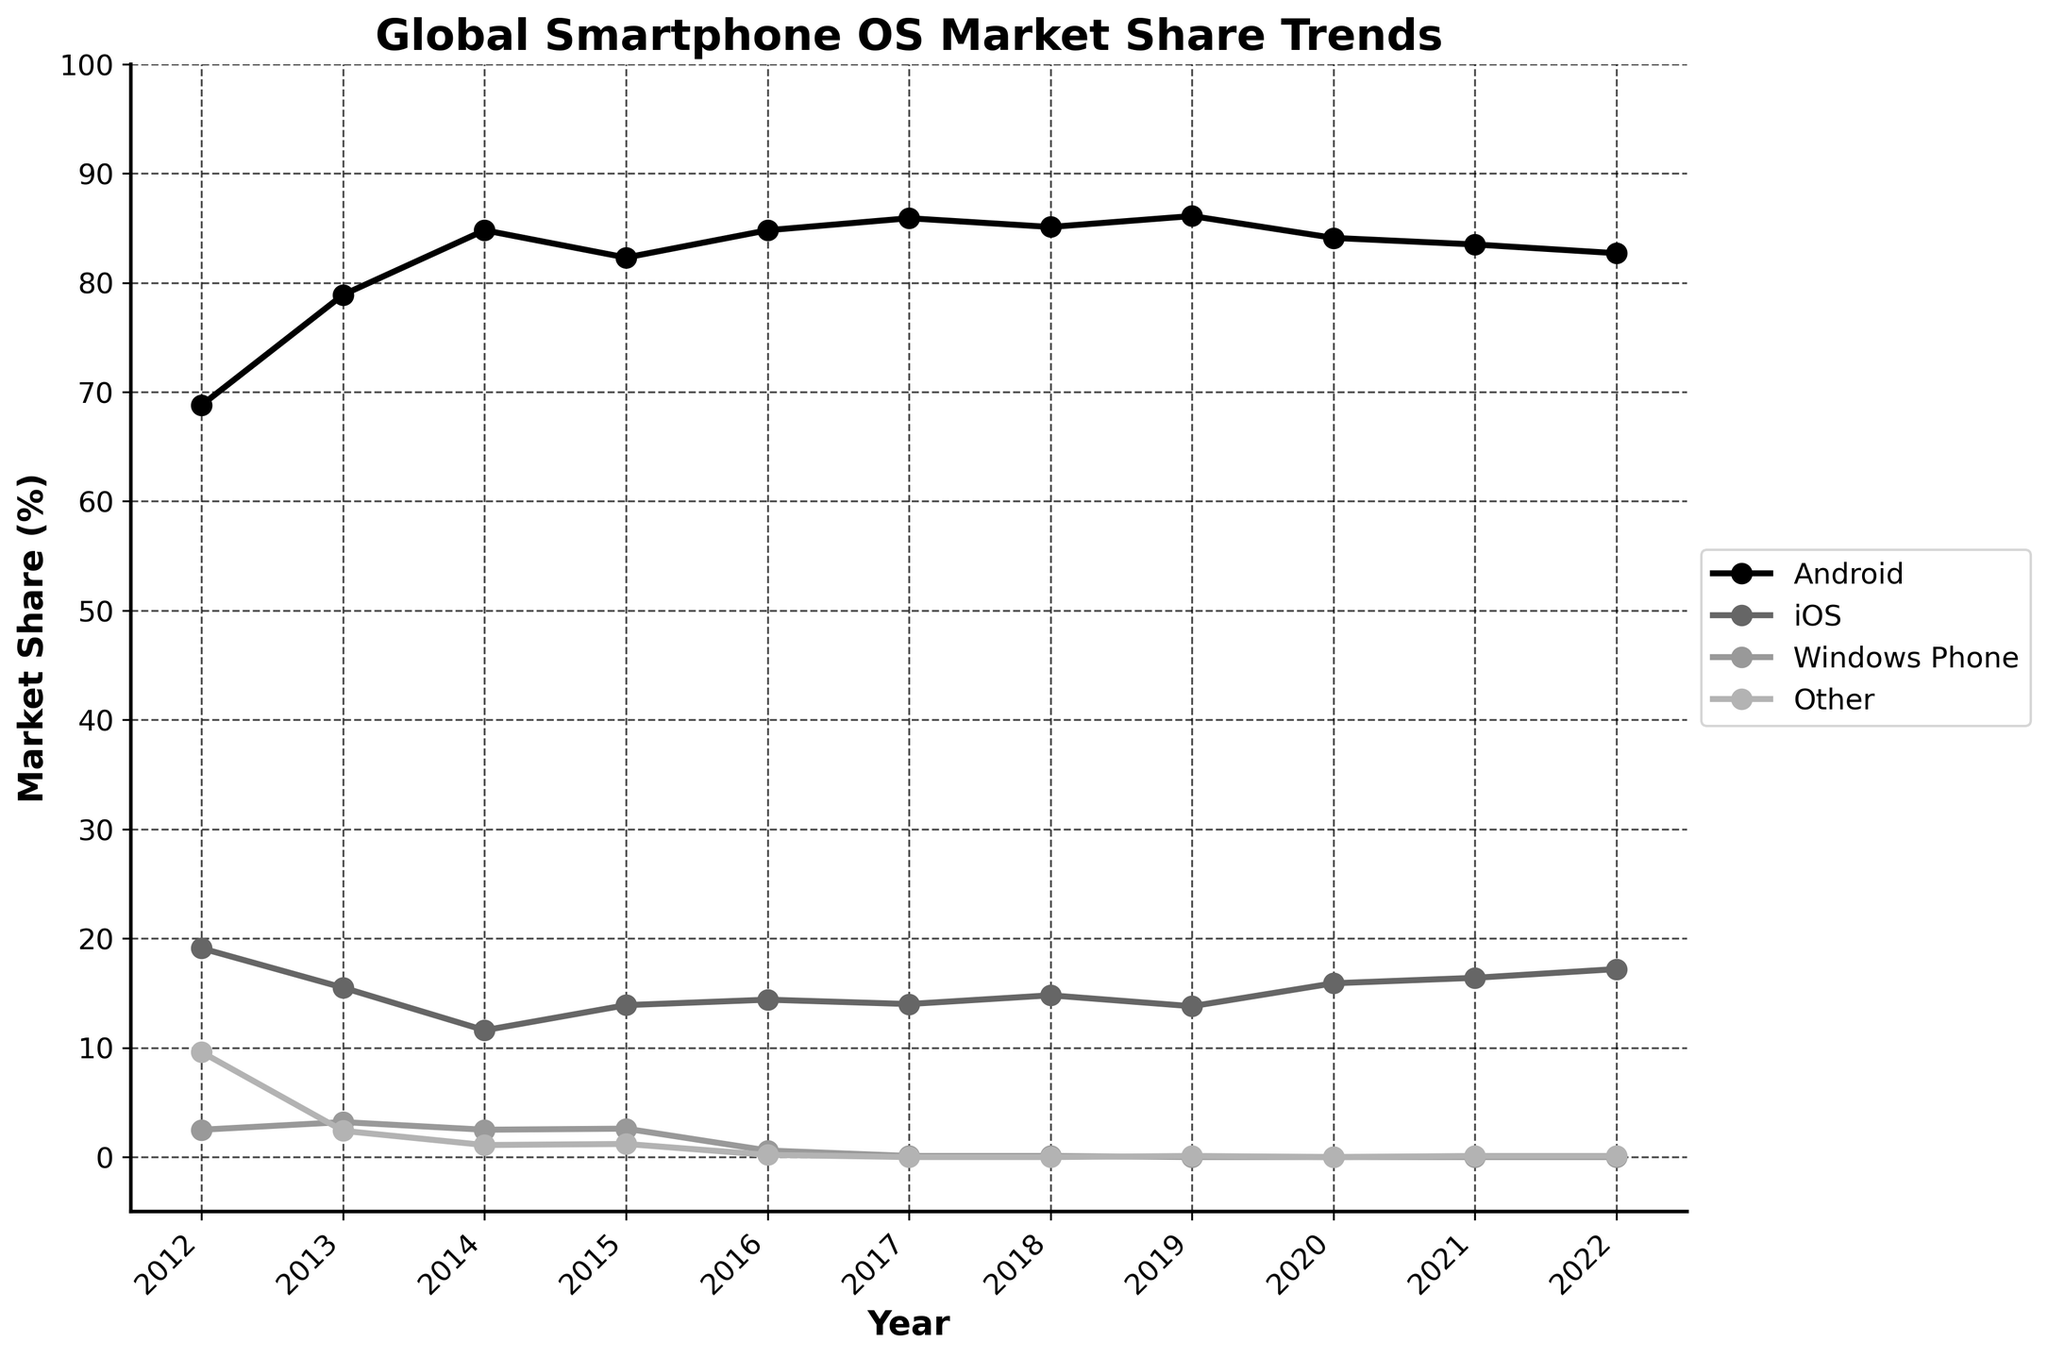Which operating system had the highest market share in 2012? In the year 2012, the line for Android is at the highest point compared to other operating systems. Looking at the y-axis readings, Android's market share is approximately 68.8%.
Answer: Android Between 2016 and 2022, did iOS ever surpass Android in market share? By analyzing the trends of the lines between 2016 and 2022, it is evident that iOS never surpasses Android. The Android line always stays above the iOS line.
Answer: No From 2014 to 2019, how did the market share of Windows Phone change? Observing the Windows Phone line from 2014 (2.5%) to 2019 (0.0%) shows a decline. The line continuously drops over these years.
Answer: Declined Which year did Android have its highest market share, and what was the percentage? The peak of the Android line appears in 2019, where its market share hits its highest point, approximately around 86.1%.
Answer: 2019, 86.1% Comparing the market share of 'Other' in 2012 and 2022, what is the difference? The 'Other' category in 2012 is at 9.6%, and in 2022 it is at 0.1%. The difference is calculated by subtracting 0.1% from 9.6%, resulting in a difference of 9.5%.
Answer: 9.5% How did the market share of iOS fluctuate between 2015 and 2020? Observing the iOS line between these years, it starts at 13.9% in 2015, rises to approximately 15.9% in 2020. Along the way, it fluctuates but generally trends upward.
Answer: Increased Which operating system showed the most significant decline over the entire decade? By observing all the lines for the decade, Windows Phone showed the most significant drop from 2.5% in 2012 to 0.0% in 2019 and remained there.
Answer: Windows Phone How many years did Android and iOS both show an increase in market share from the previous year? We must check both Android and iOS lines together. In 2013, 2016 showed both increases from 2012 and 2015 respectively. Therefore, only 2 such years exist.
Answer: 2 By looking at the steepness in the year-over-year trend, which operating system had the sharpest decline? The sharpest decline is indicated by the steepest negative slope. Windows Phone around 2016-2017 has the steepest slope, indicating the sharpest decline.
Answer: Windows Phone 